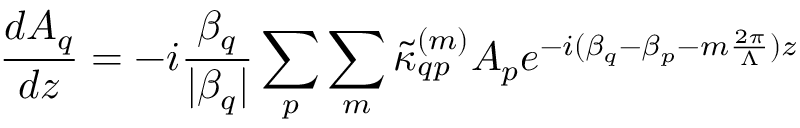<formula> <loc_0><loc_0><loc_500><loc_500>\frac { d A _ { q } } { d z } = - i \frac { \beta _ { q } } { | \beta _ { q } | } \sum _ { p } \sum _ { m } { \tilde { \kappa } _ { q p } } ^ { ( m ) } A _ { p } e ^ { - i ( \beta _ { q } - \beta _ { p } - m \frac { 2 \pi } { \Lambda } ) z }</formula> 